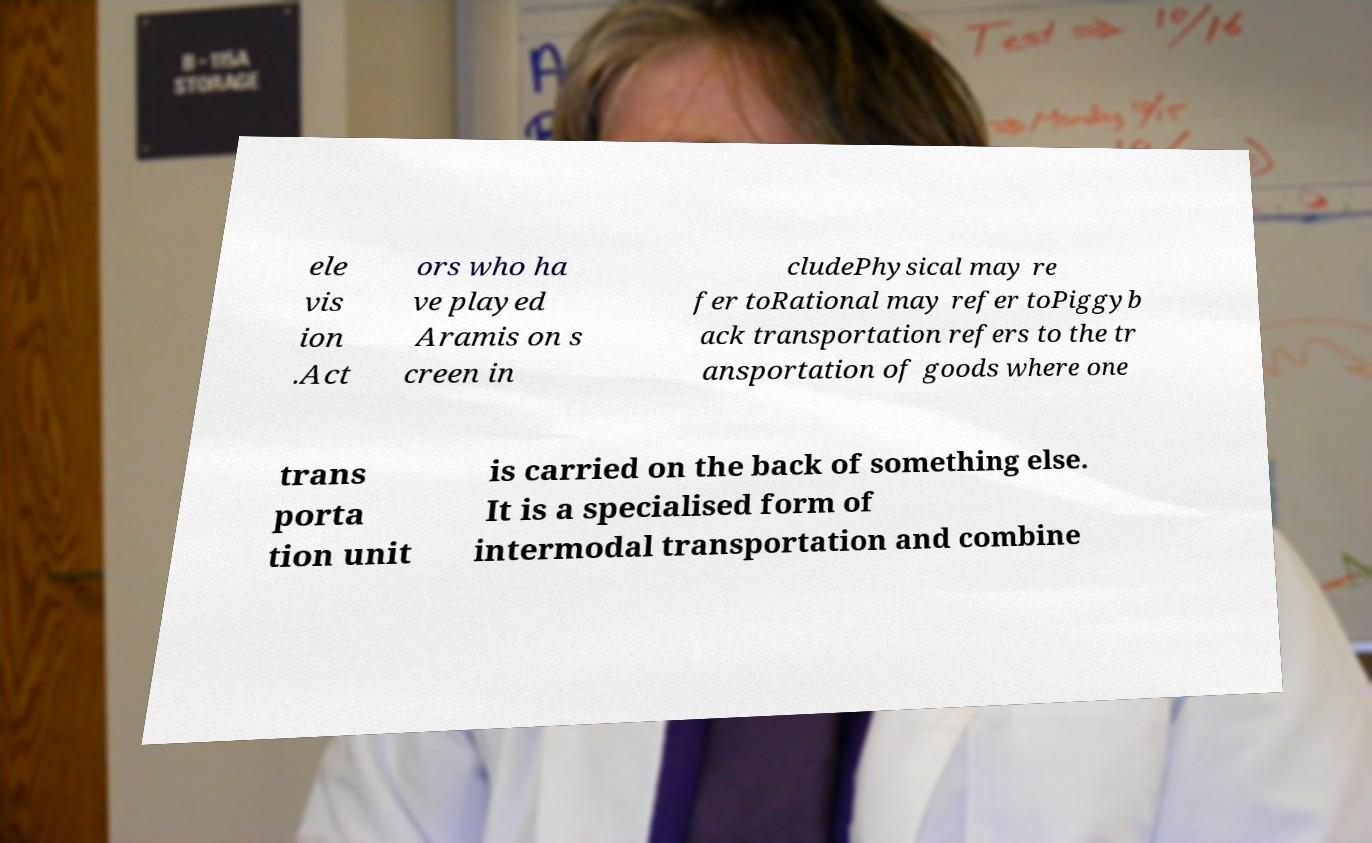Could you assist in decoding the text presented in this image and type it out clearly? ele vis ion .Act ors who ha ve played Aramis on s creen in cludePhysical may re fer toRational may refer toPiggyb ack transportation refers to the tr ansportation of goods where one trans porta tion unit is carried on the back of something else. It is a specialised form of intermodal transportation and combine 